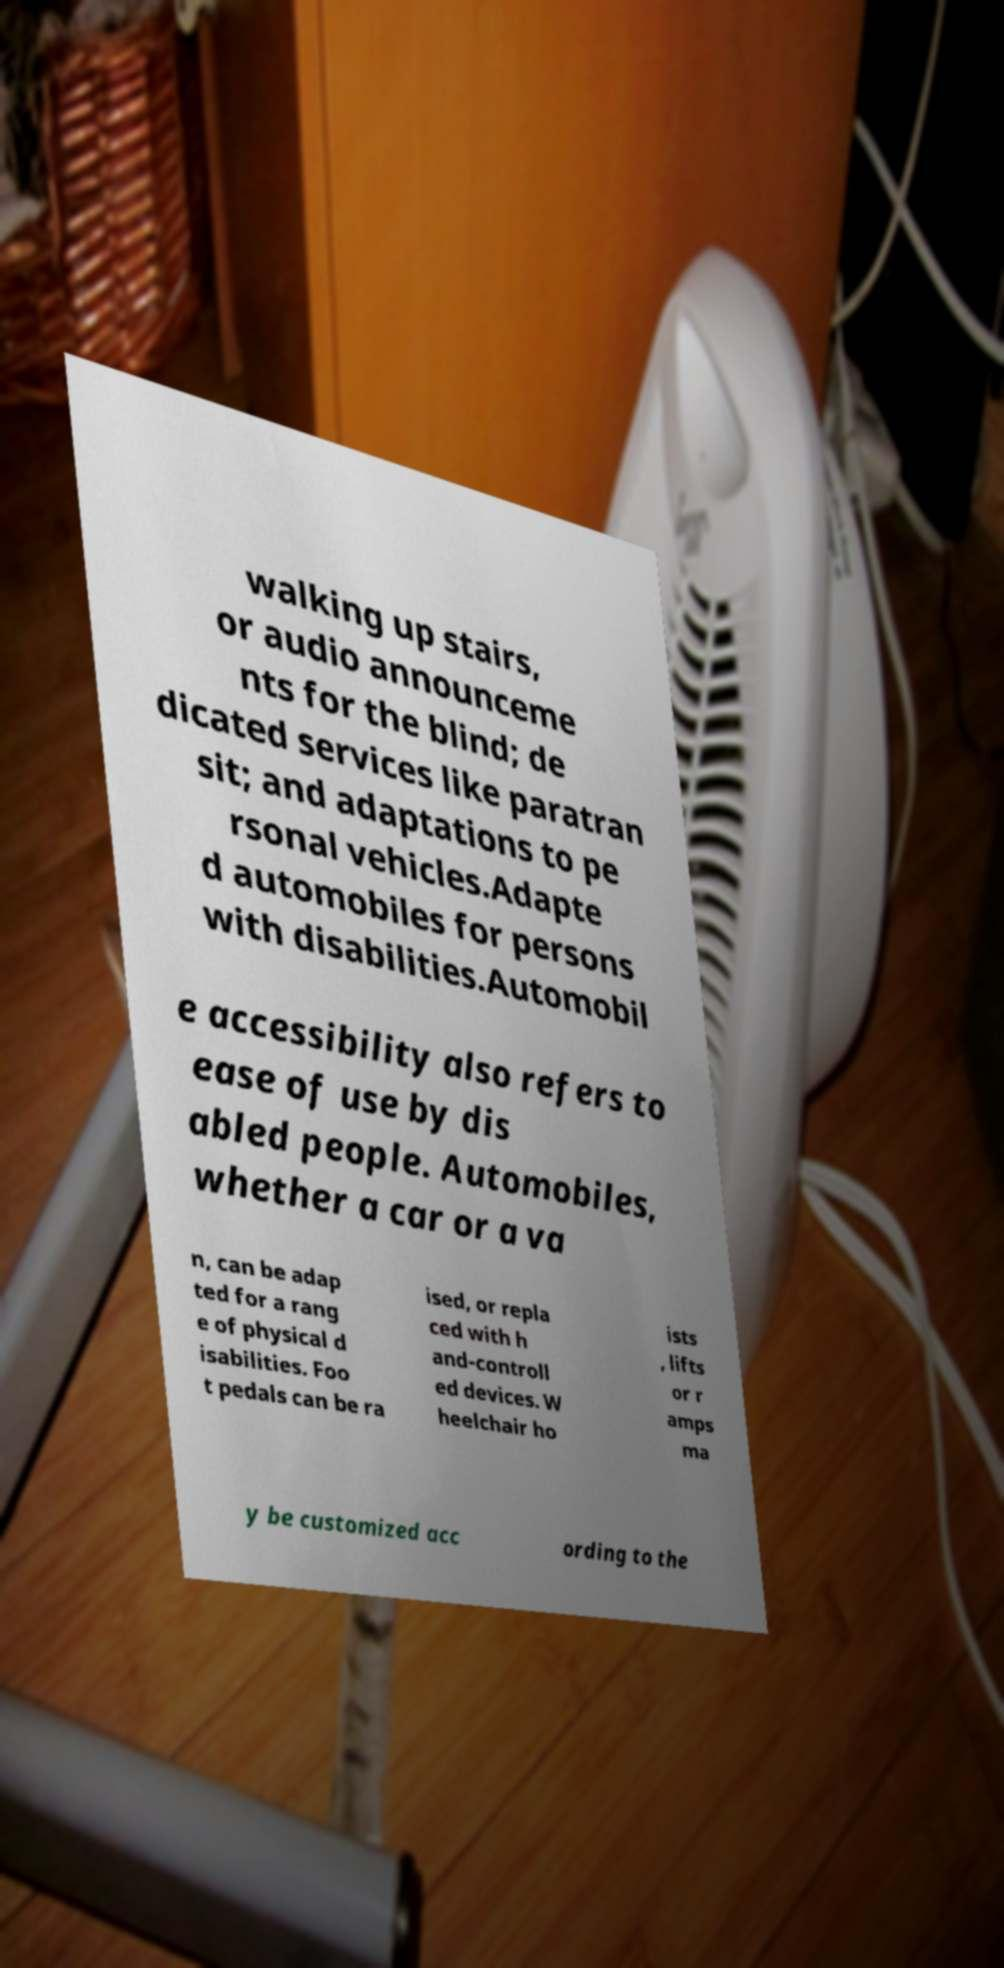Can you read and provide the text displayed in the image?This photo seems to have some interesting text. Can you extract and type it out for me? walking up stairs, or audio announceme nts for the blind; de dicated services like paratran sit; and adaptations to pe rsonal vehicles.Adapte d automobiles for persons with disabilities.Automobil e accessibility also refers to ease of use by dis abled people. Automobiles, whether a car or a va n, can be adap ted for a rang e of physical d isabilities. Foo t pedals can be ra ised, or repla ced with h and-controll ed devices. W heelchair ho ists , lifts or r amps ma y be customized acc ording to the 